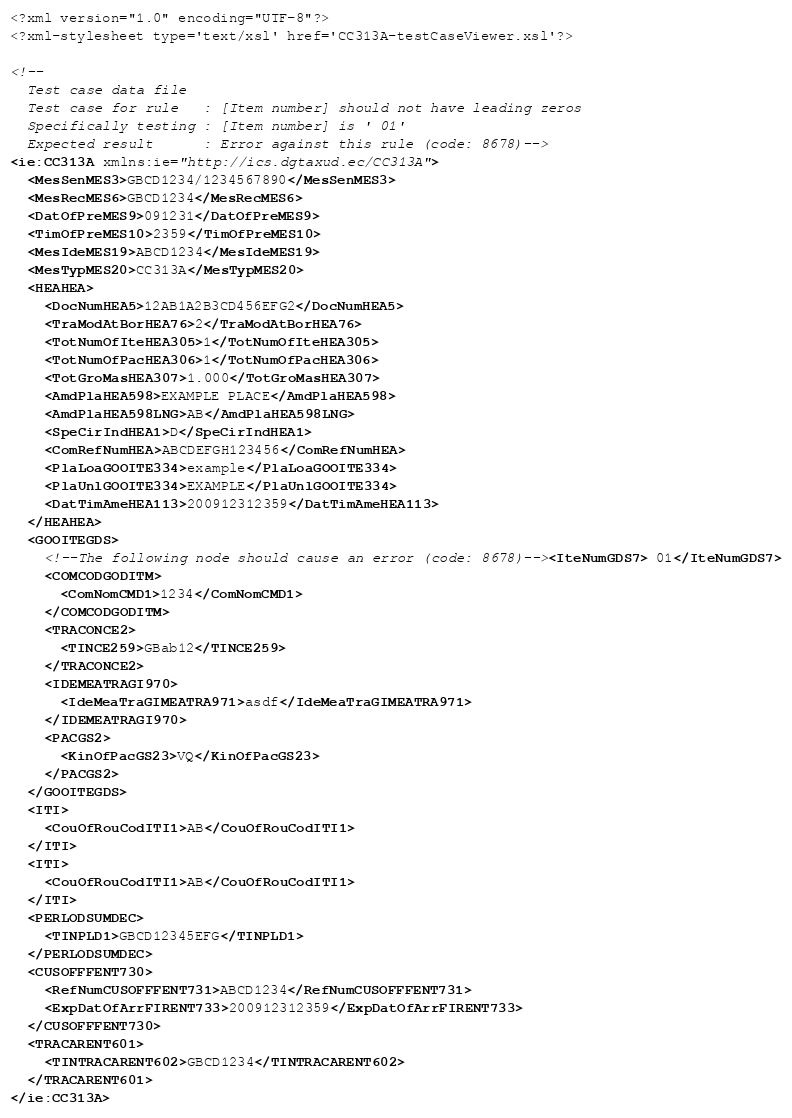<code> <loc_0><loc_0><loc_500><loc_500><_XML_><?xml version="1.0" encoding="UTF-8"?>
<?xml-stylesheet type='text/xsl' href='CC313A-testCaseViewer.xsl'?>

<!--
  Test case data file
  Test case for rule   : [Item number] should not have leading zeros
  Specifically testing : [Item number] is ' 01'
  Expected result      : Error against this rule (code: 8678)-->
<ie:CC313A xmlns:ie="http://ics.dgtaxud.ec/CC313A">
  <MesSenMES3>GBCD1234/1234567890</MesSenMES3>
  <MesRecMES6>GBCD1234</MesRecMES6>
  <DatOfPreMES9>091231</DatOfPreMES9>
  <TimOfPreMES10>2359</TimOfPreMES10>
  <MesIdeMES19>ABCD1234</MesIdeMES19>
  <MesTypMES20>CC313A</MesTypMES20>
  <HEAHEA>
    <DocNumHEA5>12AB1A2B3CD456EFG2</DocNumHEA5>
    <TraModAtBorHEA76>2</TraModAtBorHEA76>
    <TotNumOfIteHEA305>1</TotNumOfIteHEA305>
    <TotNumOfPacHEA306>1</TotNumOfPacHEA306>
    <TotGroMasHEA307>1.000</TotGroMasHEA307>
    <AmdPlaHEA598>EXAMPLE PLACE</AmdPlaHEA598>
    <AmdPlaHEA598LNG>AB</AmdPlaHEA598LNG>
    <SpeCirIndHEA1>D</SpeCirIndHEA1>
    <ComRefNumHEA>ABCDEFGH123456</ComRefNumHEA>
    <PlaLoaGOOITE334>example</PlaLoaGOOITE334>
    <PlaUnlGOOITE334>EXAMPLE</PlaUnlGOOITE334>
    <DatTimAmeHEA113>200912312359</DatTimAmeHEA113>
  </HEAHEA>
  <GOOITEGDS>
    <!--The following node should cause an error (code: 8678)--><IteNumGDS7> 01</IteNumGDS7>
    <COMCODGODITM>
      <ComNomCMD1>1234</ComNomCMD1>
    </COMCODGODITM>
    <TRACONCE2>
      <TINCE259>GBab12</TINCE259>
    </TRACONCE2>
    <IDEMEATRAGI970>
      <IdeMeaTraGIMEATRA971>asdf</IdeMeaTraGIMEATRA971>
    </IDEMEATRAGI970>
    <PACGS2>
      <KinOfPacGS23>VQ</KinOfPacGS23>
    </PACGS2>
  </GOOITEGDS>
  <ITI>
    <CouOfRouCodITI1>AB</CouOfRouCodITI1>
  </ITI>
  <ITI>
    <CouOfRouCodITI1>AB</CouOfRouCodITI1>
  </ITI>
  <PERLODSUMDEC>
    <TINPLD1>GBCD12345EFG</TINPLD1>
  </PERLODSUMDEC>
  <CUSOFFFENT730>
    <RefNumCUSOFFFENT731>ABCD1234</RefNumCUSOFFFENT731>
    <ExpDatOfArrFIRENT733>200912312359</ExpDatOfArrFIRENT733>
  </CUSOFFFENT730>
  <TRACARENT601>
    <TINTRACARENT602>GBCD1234</TINTRACARENT602>
  </TRACARENT601>
</ie:CC313A>

</code> 